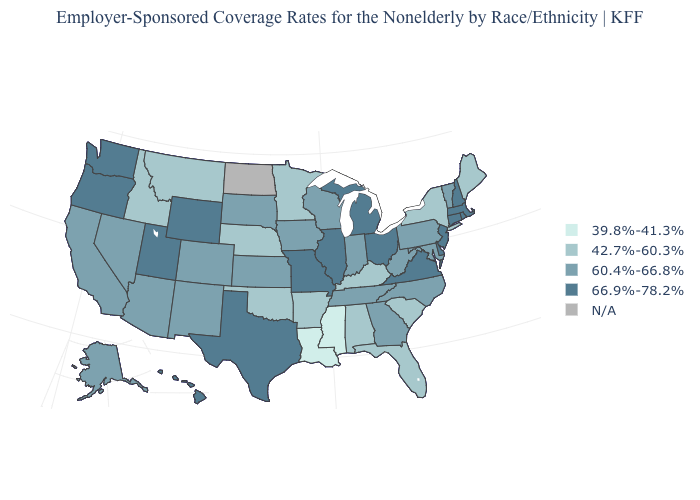Which states have the lowest value in the West?
Short answer required. Idaho, Montana. What is the value of Pennsylvania?
Answer briefly. 60.4%-66.8%. Name the states that have a value in the range 66.9%-78.2%?
Concise answer only. Connecticut, Delaware, Hawaii, Illinois, Massachusetts, Michigan, Missouri, New Hampshire, New Jersey, Ohio, Oregon, Rhode Island, Texas, Utah, Virginia, Washington, Wyoming. What is the value of Arkansas?
Write a very short answer. 42.7%-60.3%. Does the first symbol in the legend represent the smallest category?
Keep it brief. Yes. Name the states that have a value in the range 39.8%-41.3%?
Give a very brief answer. Louisiana, Mississippi. What is the value of New Hampshire?
Answer briefly. 66.9%-78.2%. Does Louisiana have the lowest value in the USA?
Give a very brief answer. Yes. Name the states that have a value in the range 60.4%-66.8%?
Be succinct. Alaska, Arizona, California, Colorado, Georgia, Indiana, Iowa, Kansas, Maryland, Nevada, New Mexico, North Carolina, Pennsylvania, South Dakota, Tennessee, Vermont, West Virginia, Wisconsin. What is the value of Minnesota?
Give a very brief answer. 42.7%-60.3%. Name the states that have a value in the range N/A?
Write a very short answer. North Dakota. What is the value of Illinois?
Keep it brief. 66.9%-78.2%. Does New Jersey have the highest value in the USA?
Concise answer only. Yes. Name the states that have a value in the range 66.9%-78.2%?
Answer briefly. Connecticut, Delaware, Hawaii, Illinois, Massachusetts, Michigan, Missouri, New Hampshire, New Jersey, Ohio, Oregon, Rhode Island, Texas, Utah, Virginia, Washington, Wyoming. 